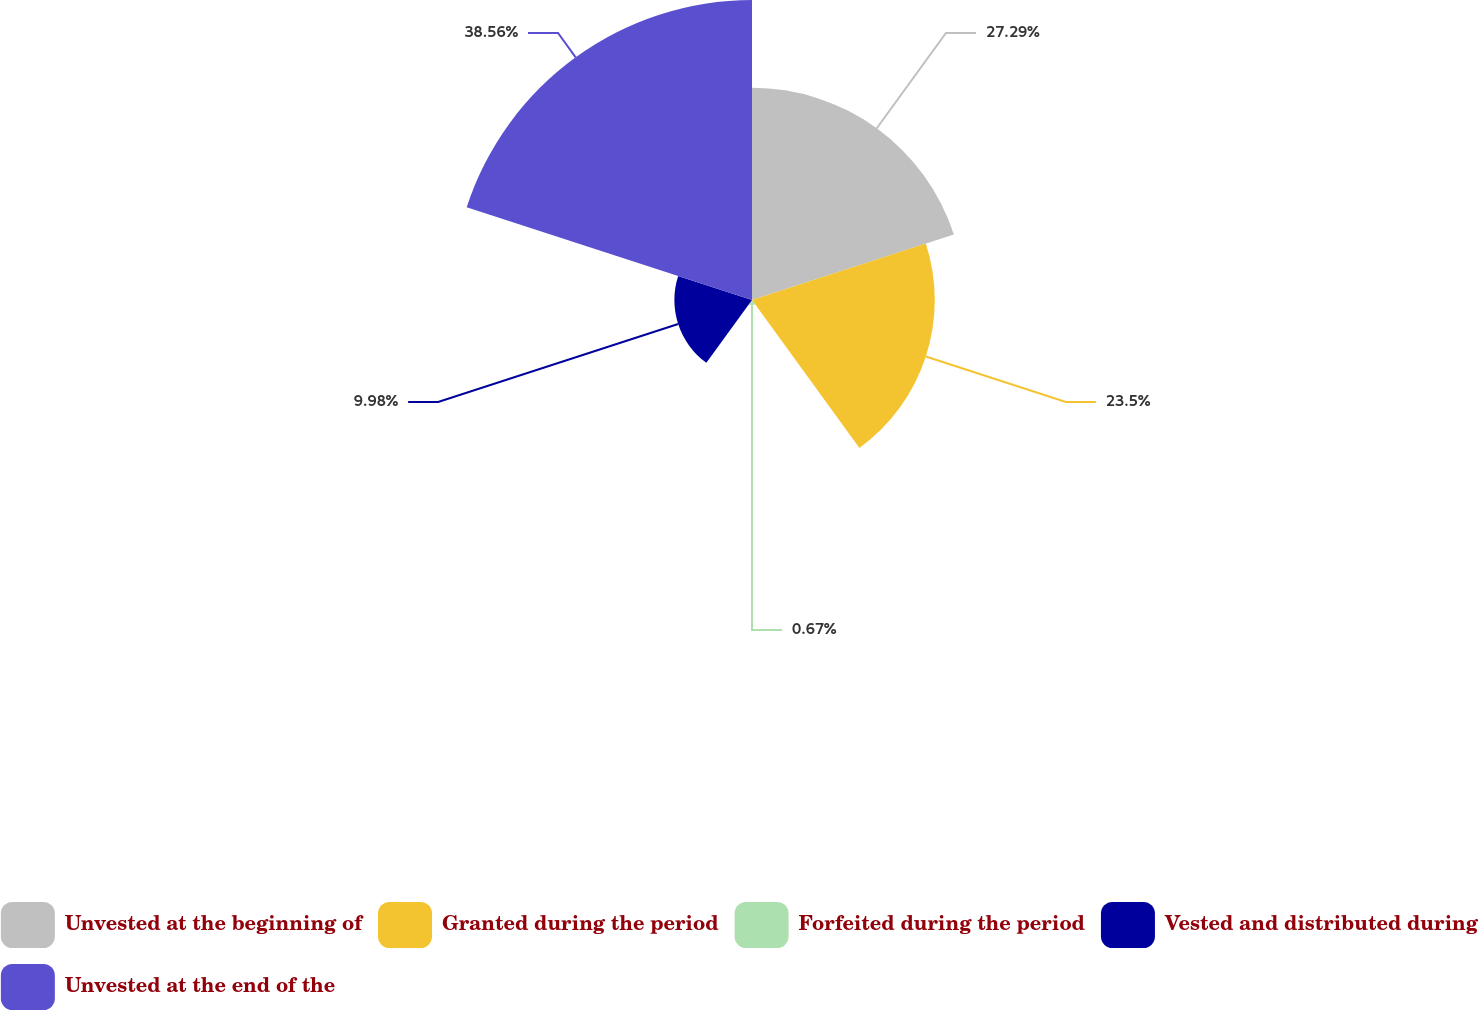Convert chart. <chart><loc_0><loc_0><loc_500><loc_500><pie_chart><fcel>Unvested at the beginning of<fcel>Granted during the period<fcel>Forfeited during the period<fcel>Vested and distributed during<fcel>Unvested at the end of the<nl><fcel>27.29%<fcel>23.5%<fcel>0.67%<fcel>9.98%<fcel>38.57%<nl></chart> 